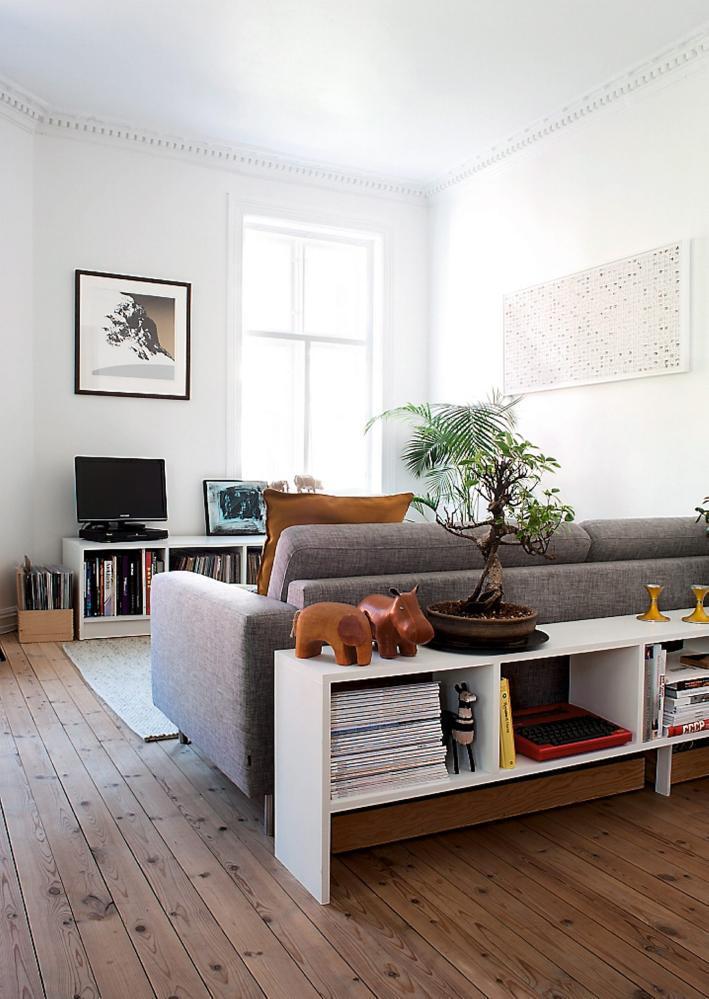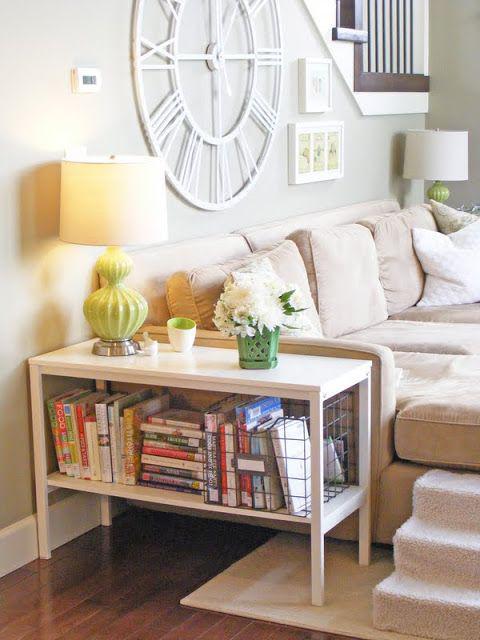The first image is the image on the left, the second image is the image on the right. Examine the images to the left and right. Is the description "A black bookshelf sits against the wall in one of the images." accurate? Answer yes or no. No. The first image is the image on the left, the second image is the image on the right. Assess this claim about the two images: "An image shows a sofa with neutral ecru cushions and bookshelves built into the sides.". Correct or not? Answer yes or no. No. 